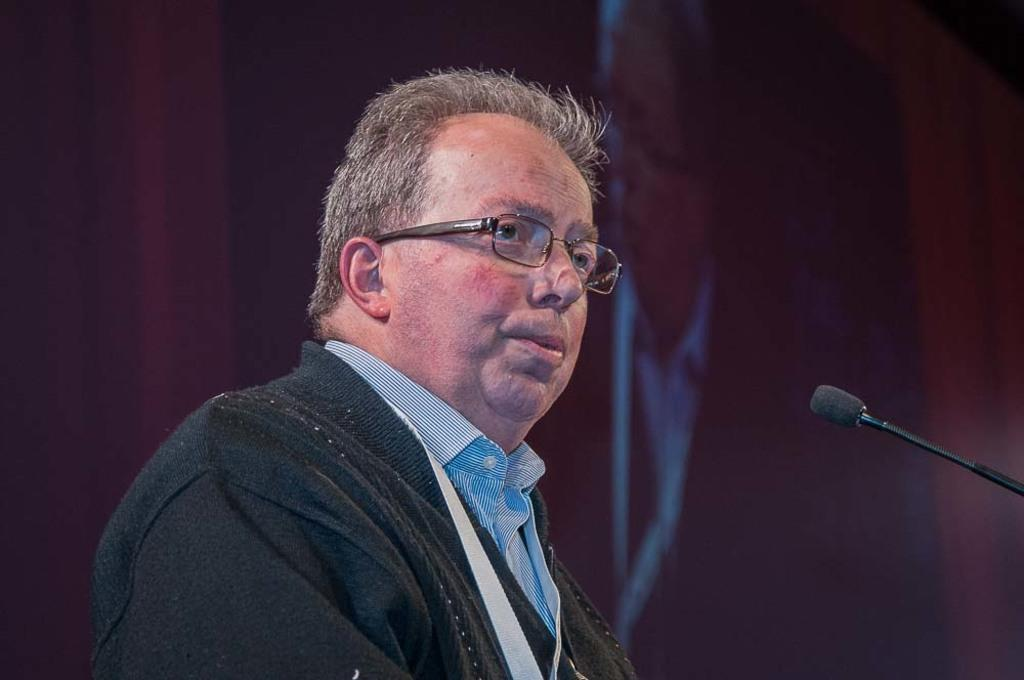What is the general color scheme of the image? The background of the image is dark. What object is present in the image that might be used for displaying information or media? A screen is visible in the image. Can you describe the person in the image? There is a man wearing spectacles in the image. Where is the microphone located in the image? The microphone is on the right side of the image. What time is displayed on the clock in the image? There is no clock present in the image. What type of yoke is being used by the man in the image? The image does not show a yoke or any indication that the man is using one. 